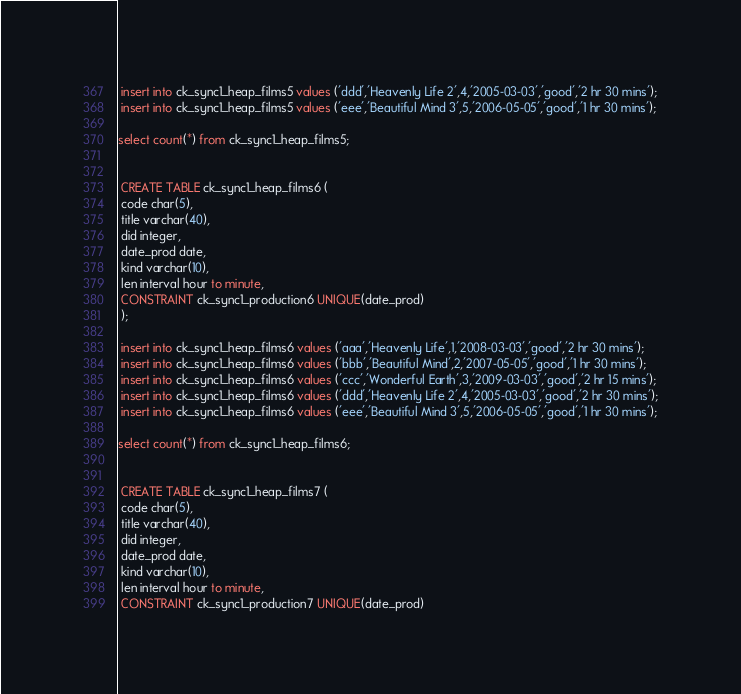<code> <loc_0><loc_0><loc_500><loc_500><_SQL_> insert into ck_sync1_heap_films5 values ('ddd','Heavenly Life 2',4,'2005-03-03','good','2 hr 30 mins');
 insert into ck_sync1_heap_films5 values ('eee','Beautiful Mind 3',5,'2006-05-05','good','1 hr 30 mins');

select count(*) from ck_sync1_heap_films5;


 CREATE TABLE ck_sync1_heap_films6 (
 code char(5),
 title varchar(40),
 did integer,
 date_prod date,
 kind varchar(10),
 len interval hour to minute,
 CONSTRAINT ck_sync1_production6 UNIQUE(date_prod)
 );

 insert into ck_sync1_heap_films6 values ('aaa','Heavenly Life',1,'2008-03-03','good','2 hr 30 mins');
 insert into ck_sync1_heap_films6 values ('bbb','Beautiful Mind',2,'2007-05-05','good','1 hr 30 mins');
 insert into ck_sync1_heap_films6 values ('ccc','Wonderful Earth',3,'2009-03-03','good','2 hr 15 mins');
 insert into ck_sync1_heap_films6 values ('ddd','Heavenly Life 2',4,'2005-03-03','good','2 hr 30 mins');
 insert into ck_sync1_heap_films6 values ('eee','Beautiful Mind 3',5,'2006-05-05','good','1 hr 30 mins');

select count(*) from ck_sync1_heap_films6;


 CREATE TABLE ck_sync1_heap_films7 (
 code char(5),
 title varchar(40),
 did integer,
 date_prod date,
 kind varchar(10),
 len interval hour to minute,
 CONSTRAINT ck_sync1_production7 UNIQUE(date_prod)</code> 